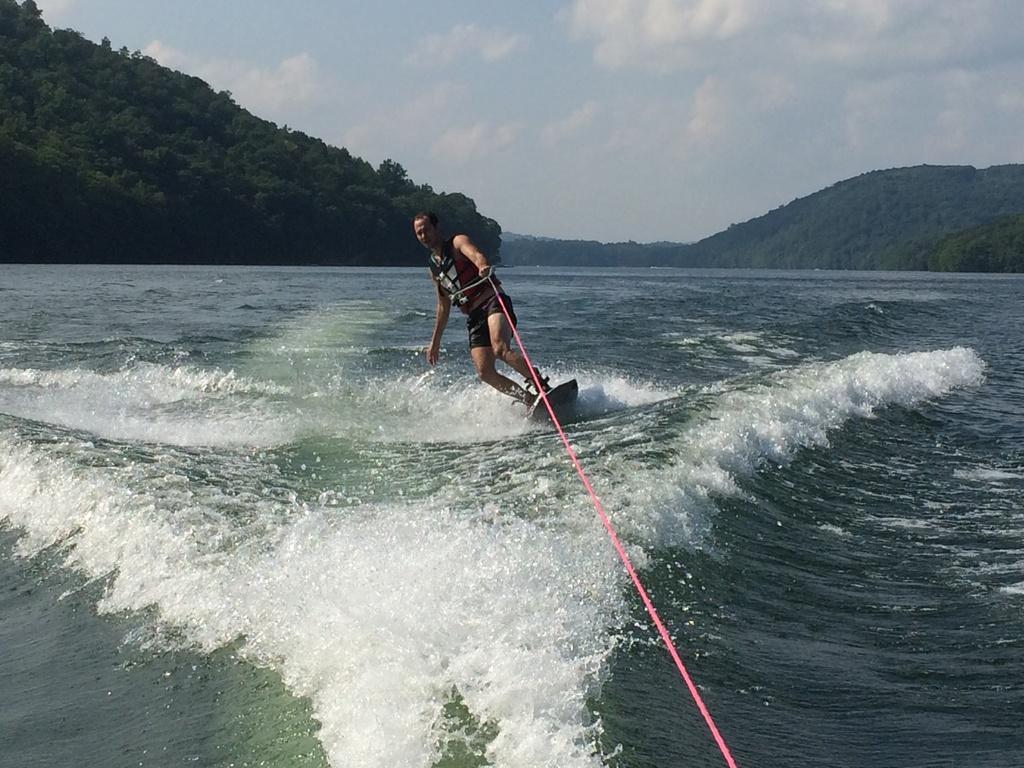Could you give a brief overview of what you see in this image? Here a man is doing surfing in the sea. In the left side there are trees on a hill, in the middle at the top it's a sky. 